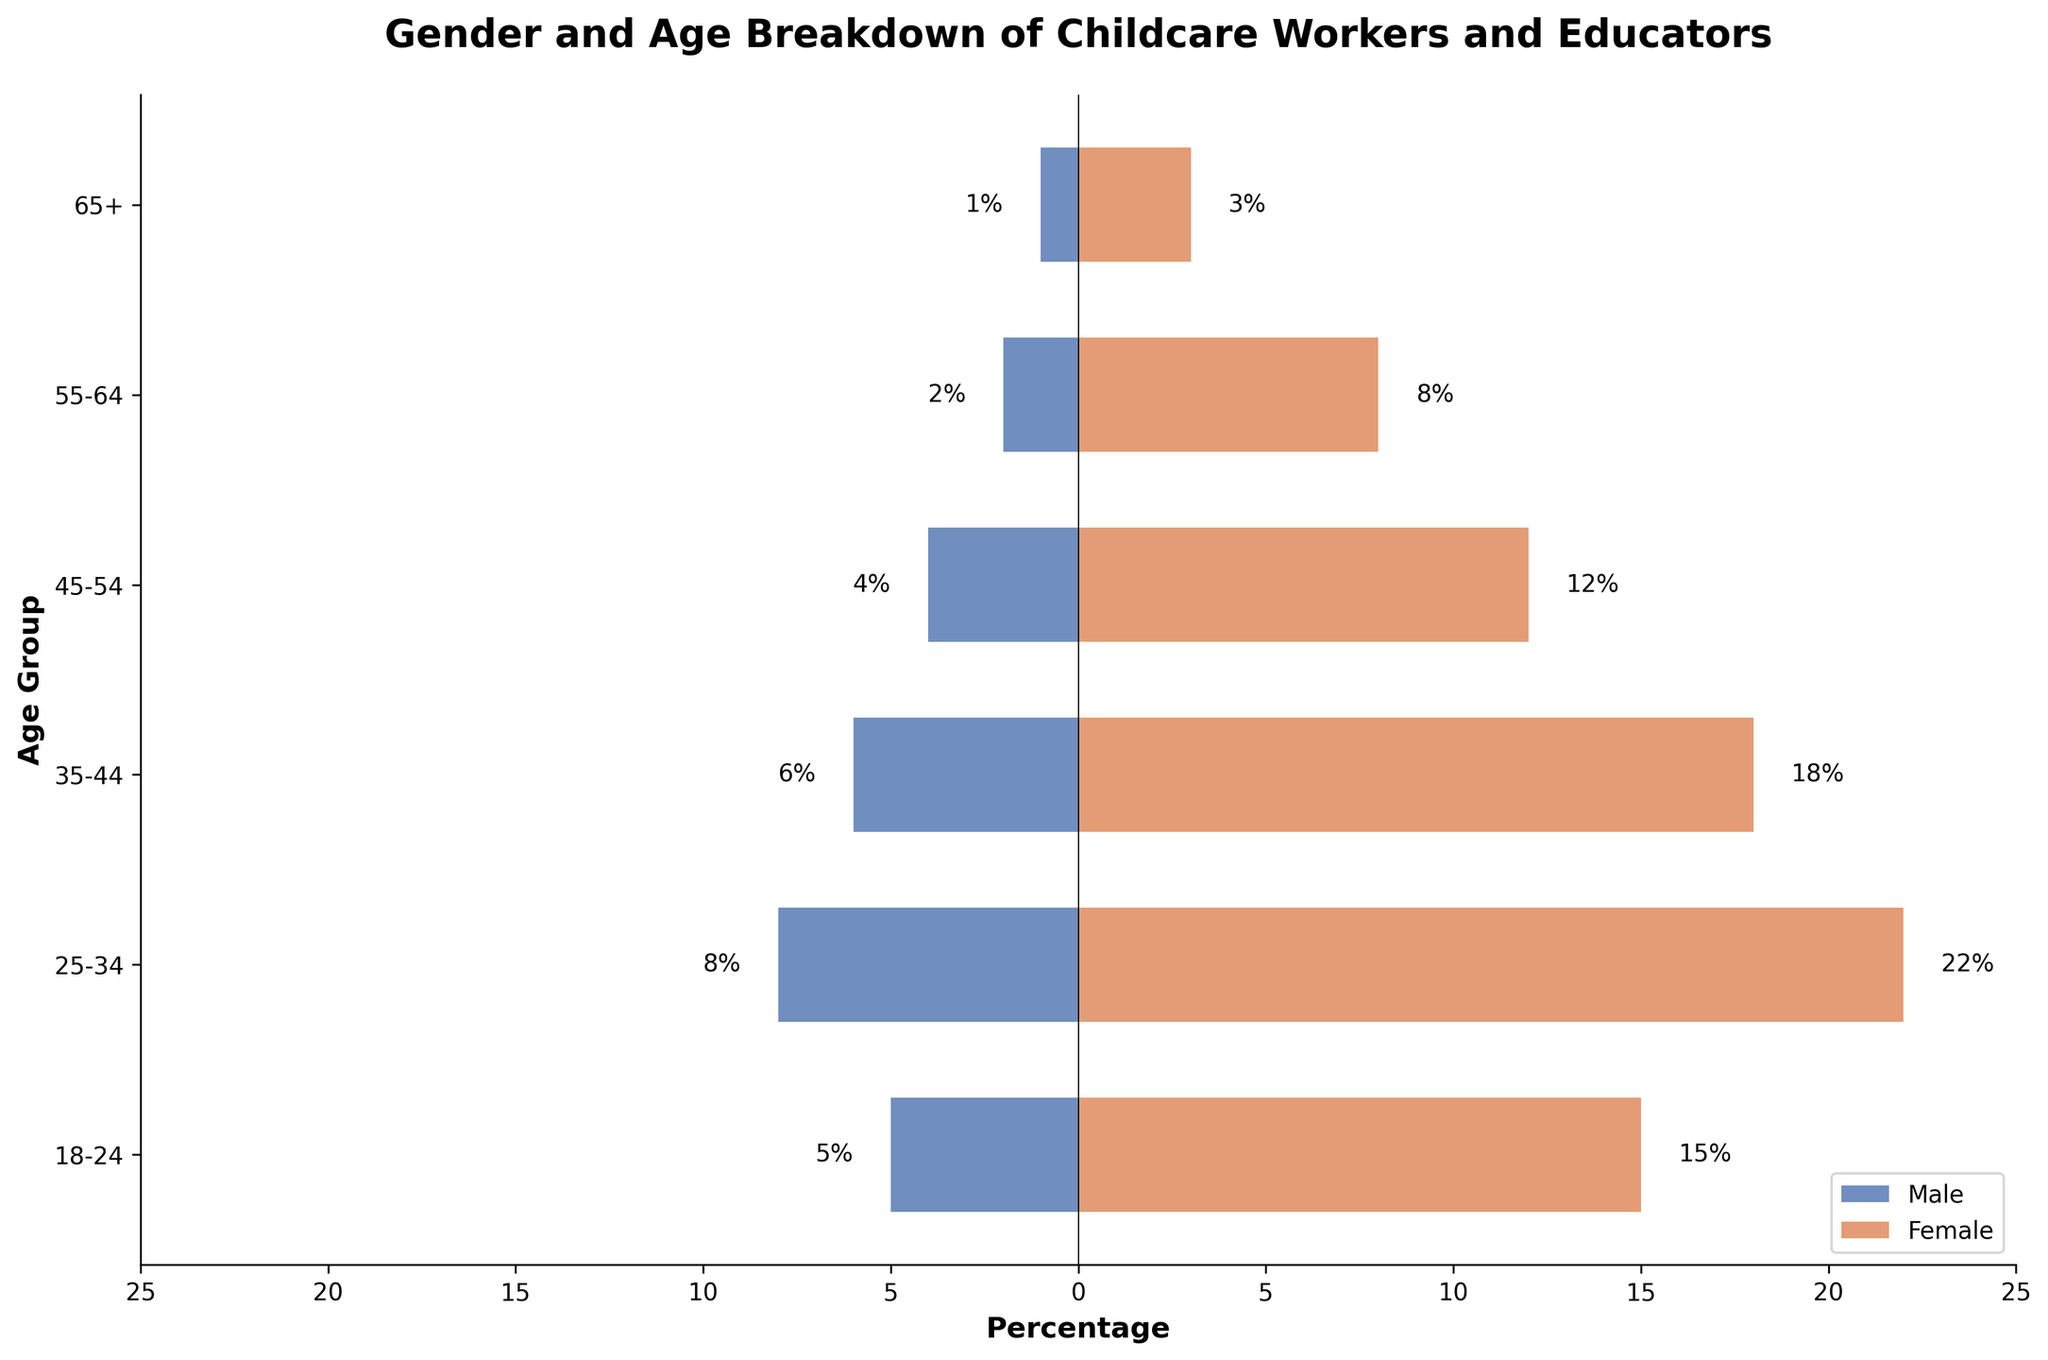What's the title of the figure? Look at the top of the figure where the title is displayed.
Answer: Gender and Age Breakdown of Childcare Workers and Educators What do the colors represent in the bars? The legend at the bottom right of the figure indicates that blue bars represent males and orange bars represent females.
Answer: Blue: Male, Orange: Female Which age group has the highest percentage of male childcare workers and educators? Compare the lengths of the blue bars on the horizontal axis. The longest blue bar corresponds to the age group with the highest percentage of males.
Answer: 25-34 How many total childcare workers and educators are there in the 45-54 age group? Add the number of males and females in the 45-54 age group (4 males + 12 females).
Answer: 16 Which age group has a higher percentage of females compared to males? Compare the lengths of the blue and orange bars within each age group. Identify any age group where the orange bar is longer than the blue bar.
Answer: All age groups In which age group is the difference between the percentage of male and female childcare workers and educators the smallest? Calculate the difference in percentages for each age group and find the age group with the smallest difference. (25-34: 22-8=14, 18-24: 15-5=10, etc.)
Answer: 65+ What is the total percentage of childcare workers and educators aged 25-34 across both genders? Add the percentages of males and females in the 25-34 age group (8% males + 22% females).
Answer: 30% How do the age groups 18-24 and 55-64 compare in terms of total number of female workers? Compare the lengths of the orange bars for the 18-24 and 55-64 age groups by noting the values at the end of the bars (18-24: 15 females, 55-64: 8 females).
Answer: 18-24 has more females Is there a clear trend in terms of the gender distribution as the age groups progress from younger to older? Examine the lengths of the blue and orange bars across the age groups to look for any visible trends. Generally, the orange bars are consistently longer, indicating a higher percentage of females across all age groups.
Answer: More females than males across all age groups What is the difference in the total number of workers between the oldest (65+) and youngest (18-24) age groups? Subtract the total number of workers in the 65+ age group from the total number in the 18-24 age group [(5+15) - (1+3)].
Answer: 16 